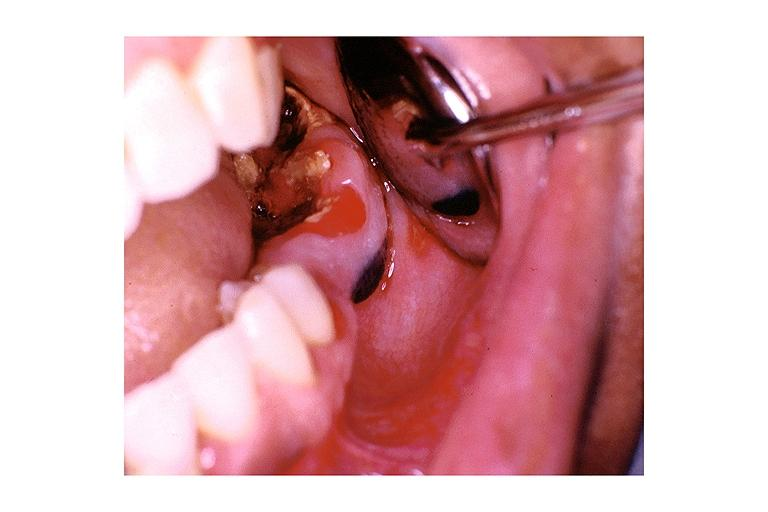s oral present?
Answer the question using a single word or phrase. Yes 